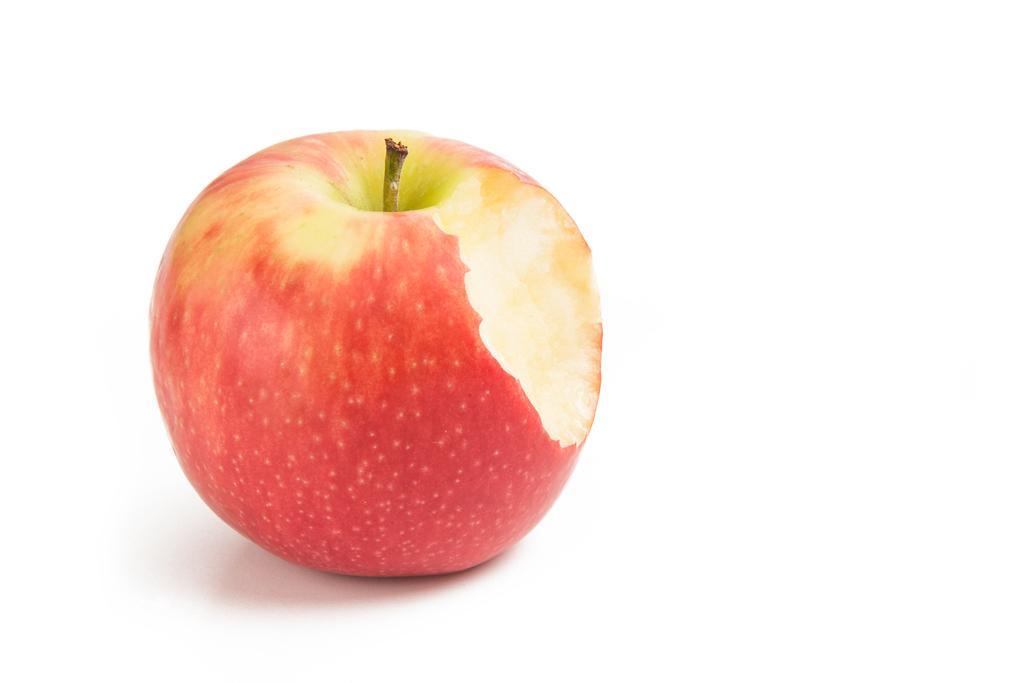Describe this image in one or two sentences. In this picture we can see an apple and this apple is placed on a white platform. 